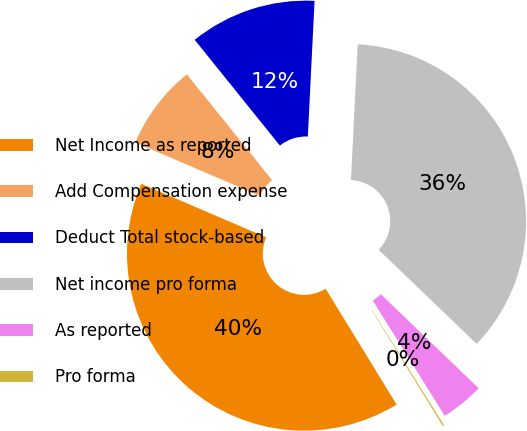Convert chart. <chart><loc_0><loc_0><loc_500><loc_500><pie_chart><fcel>Net Income as reported<fcel>Add Compensation expense<fcel>Deduct Total stock-based<fcel>Net income pro forma<fcel>As reported<fcel>Pro forma<nl><fcel>40.2%<fcel>7.76%<fcel>11.58%<fcel>36.39%<fcel>3.94%<fcel>0.13%<nl></chart> 